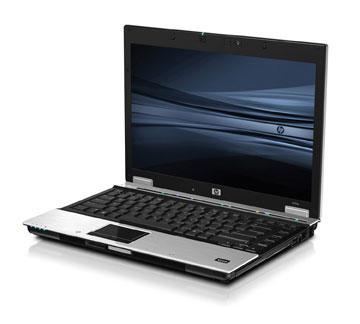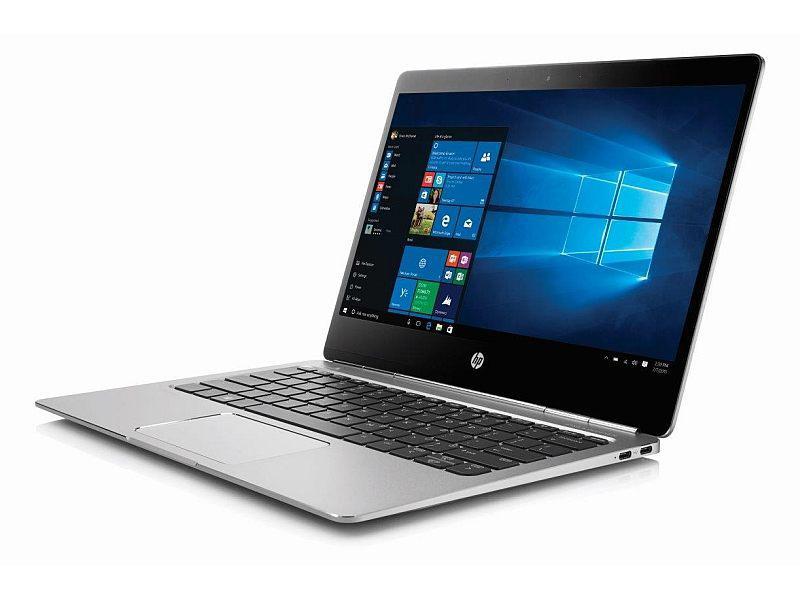The first image is the image on the left, the second image is the image on the right. Given the left and right images, does the statement "All laptops are angled with the open screen facing rightward, and one laptop features a blue screen with a white circle logo on it." hold true? Answer yes or no. No. The first image is the image on the left, the second image is the image on the right. Examine the images to the left and right. Is the description "there is a laptop with a screen showing a windows logo with light shining through the window" accurate? Answer yes or no. Yes. 